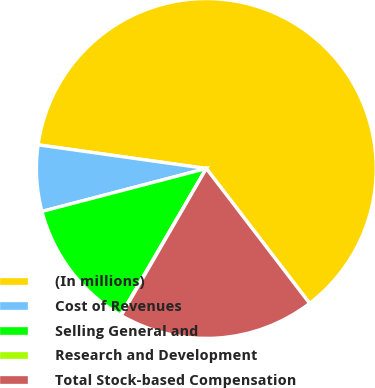Convert chart. <chart><loc_0><loc_0><loc_500><loc_500><pie_chart><fcel>(In millions)<fcel>Cost of Revenues<fcel>Selling General and<fcel>Research and Development<fcel>Total Stock-based Compensation<nl><fcel>62.37%<fcel>6.29%<fcel>12.52%<fcel>0.06%<fcel>18.75%<nl></chart> 